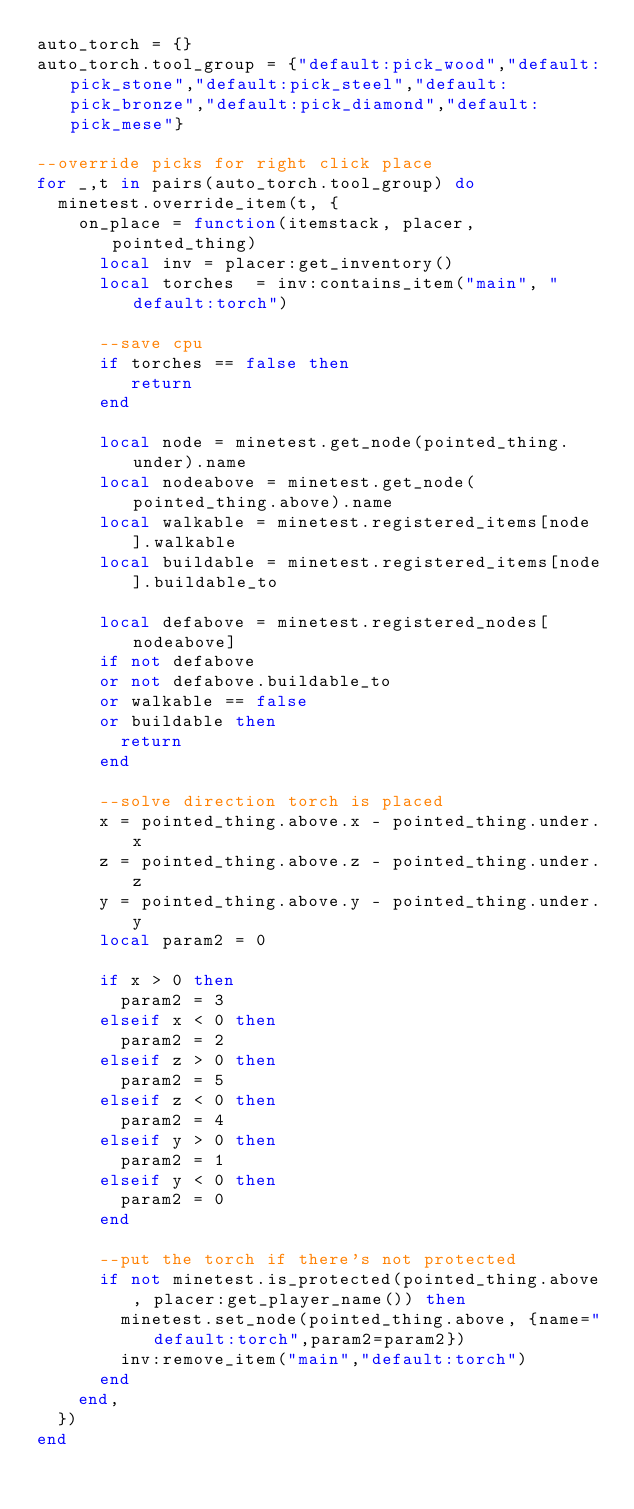<code> <loc_0><loc_0><loc_500><loc_500><_Lua_>auto_torch = {}
auto_torch.tool_group = {"default:pick_wood","default:pick_stone","default:pick_steel","default:pick_bronze","default:pick_diamond","default:pick_mese"}

--override picks for right click place
for _,t in pairs(auto_torch.tool_group) do
	minetest.override_item(t, {
		on_place = function(itemstack, placer, pointed_thing)
			local inv = placer:get_inventory()
			local torches  = inv:contains_item("main", "default:torch")
			
			--save cpu
			if torches == false then
				 return
			end
			
			local node = minetest.get_node(pointed_thing.under).name
			local nodeabove = minetest.get_node(pointed_thing.above).name
			local walkable = minetest.registered_items[node].walkable
			local buildable = minetest.registered_items[node].buildable_to
			
			local defabove = minetest.registered_nodes[nodeabove]
			if not defabove
			or not defabove.buildable_to
			or walkable == false
			or buildable then
				return
			end
		
			--solve direction torch is placed
			x = pointed_thing.above.x - pointed_thing.under.x
			z = pointed_thing.above.z - pointed_thing.under.z
			y = pointed_thing.above.y - pointed_thing.under.y
			local param2 = 0
			
			if x > 0 then
				param2 = 3
			elseif x < 0 then
				param2 = 2
			elseif z > 0 then
				param2 = 5
			elseif z < 0 then
				param2 = 4
			elseif y > 0 then
				param2 = 1
			elseif y < 0 then
				param2 = 0
			end
			
			--put the torch if there's not protected
			if not minetest.is_protected(pointed_thing.above, placer:get_player_name()) then
				minetest.set_node(pointed_thing.above, {name="default:torch",param2=param2}) 
				inv:remove_item("main","default:torch")
			end
		end,
	})
end
</code> 